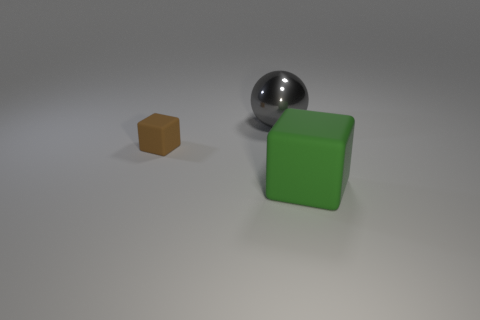How many things are either green matte cylinders or rubber cubes?
Keep it short and to the point. 2. Is the size of the block to the right of the shiny thing the same as the big gray shiny sphere?
Your answer should be compact. Yes. There is a thing that is both behind the green matte object and on the right side of the small rubber block; how big is it?
Keep it short and to the point. Large. How many other objects are there of the same shape as the green object?
Provide a succinct answer. 1. How many other things are there of the same material as the ball?
Give a very brief answer. 0. What size is the other thing that is the same shape as the green matte thing?
Give a very brief answer. Small. The thing that is both to the right of the brown thing and in front of the big metal object is what color?
Provide a short and direct response. Green. How many things are either rubber objects that are to the left of the big matte thing or small blue balls?
Provide a short and direct response. 1. There is a tiny object that is the same shape as the large green rubber thing; what is its color?
Make the answer very short. Brown. There is a brown object; is it the same shape as the object that is on the right side of the big gray metal sphere?
Your answer should be very brief. Yes. 